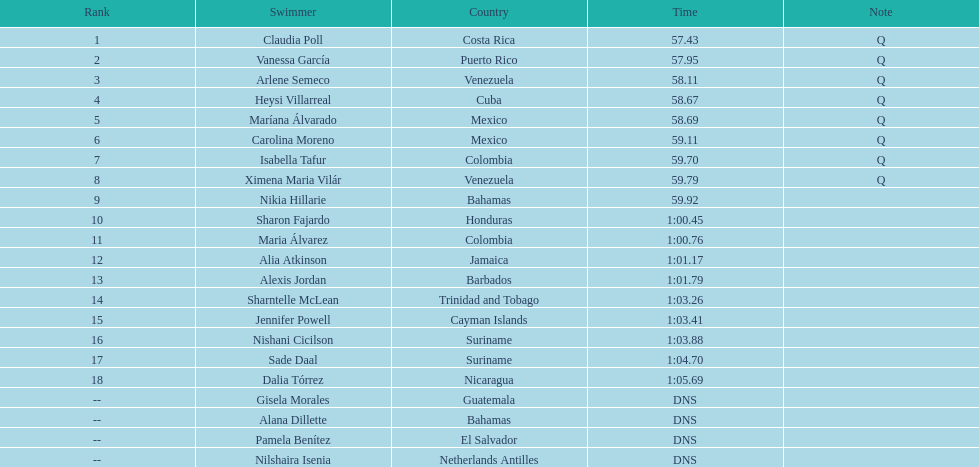Who was the ultimate competitor to actually conclude the preliminary rounds? Dalia Tórrez. Write the full table. {'header': ['Rank', 'Swimmer', 'Country', 'Time', 'Note'], 'rows': [['1', 'Claudia Poll', 'Costa Rica', '57.43', 'Q'], ['2', 'Vanessa García', 'Puerto Rico', '57.95', 'Q'], ['3', 'Arlene Semeco', 'Venezuela', '58.11', 'Q'], ['4', 'Heysi Villarreal', 'Cuba', '58.67', 'Q'], ['5', 'Maríana Álvarado', 'Mexico', '58.69', 'Q'], ['6', 'Carolina Moreno', 'Mexico', '59.11', 'Q'], ['7', 'Isabella Tafur', 'Colombia', '59.70', 'Q'], ['8', 'Ximena Maria Vilár', 'Venezuela', '59.79', 'Q'], ['9', 'Nikia Hillarie', 'Bahamas', '59.92', ''], ['10', 'Sharon Fajardo', 'Honduras', '1:00.45', ''], ['11', 'Maria Álvarez', 'Colombia', '1:00.76', ''], ['12', 'Alia Atkinson', 'Jamaica', '1:01.17', ''], ['13', 'Alexis Jordan', 'Barbados', '1:01.79', ''], ['14', 'Sharntelle McLean', 'Trinidad and Tobago', '1:03.26', ''], ['15', 'Jennifer Powell', 'Cayman Islands', '1:03.41', ''], ['16', 'Nishani Cicilson', 'Suriname', '1:03.88', ''], ['17', 'Sade Daal', 'Suriname', '1:04.70', ''], ['18', 'Dalia Tórrez', 'Nicaragua', '1:05.69', ''], ['--', 'Gisela Morales', 'Guatemala', 'DNS', ''], ['--', 'Alana Dillette', 'Bahamas', 'DNS', ''], ['--', 'Pamela Benítez', 'El Salvador', 'DNS', ''], ['--', 'Nilshaira Isenia', 'Netherlands Antilles', 'DNS', '']]} 